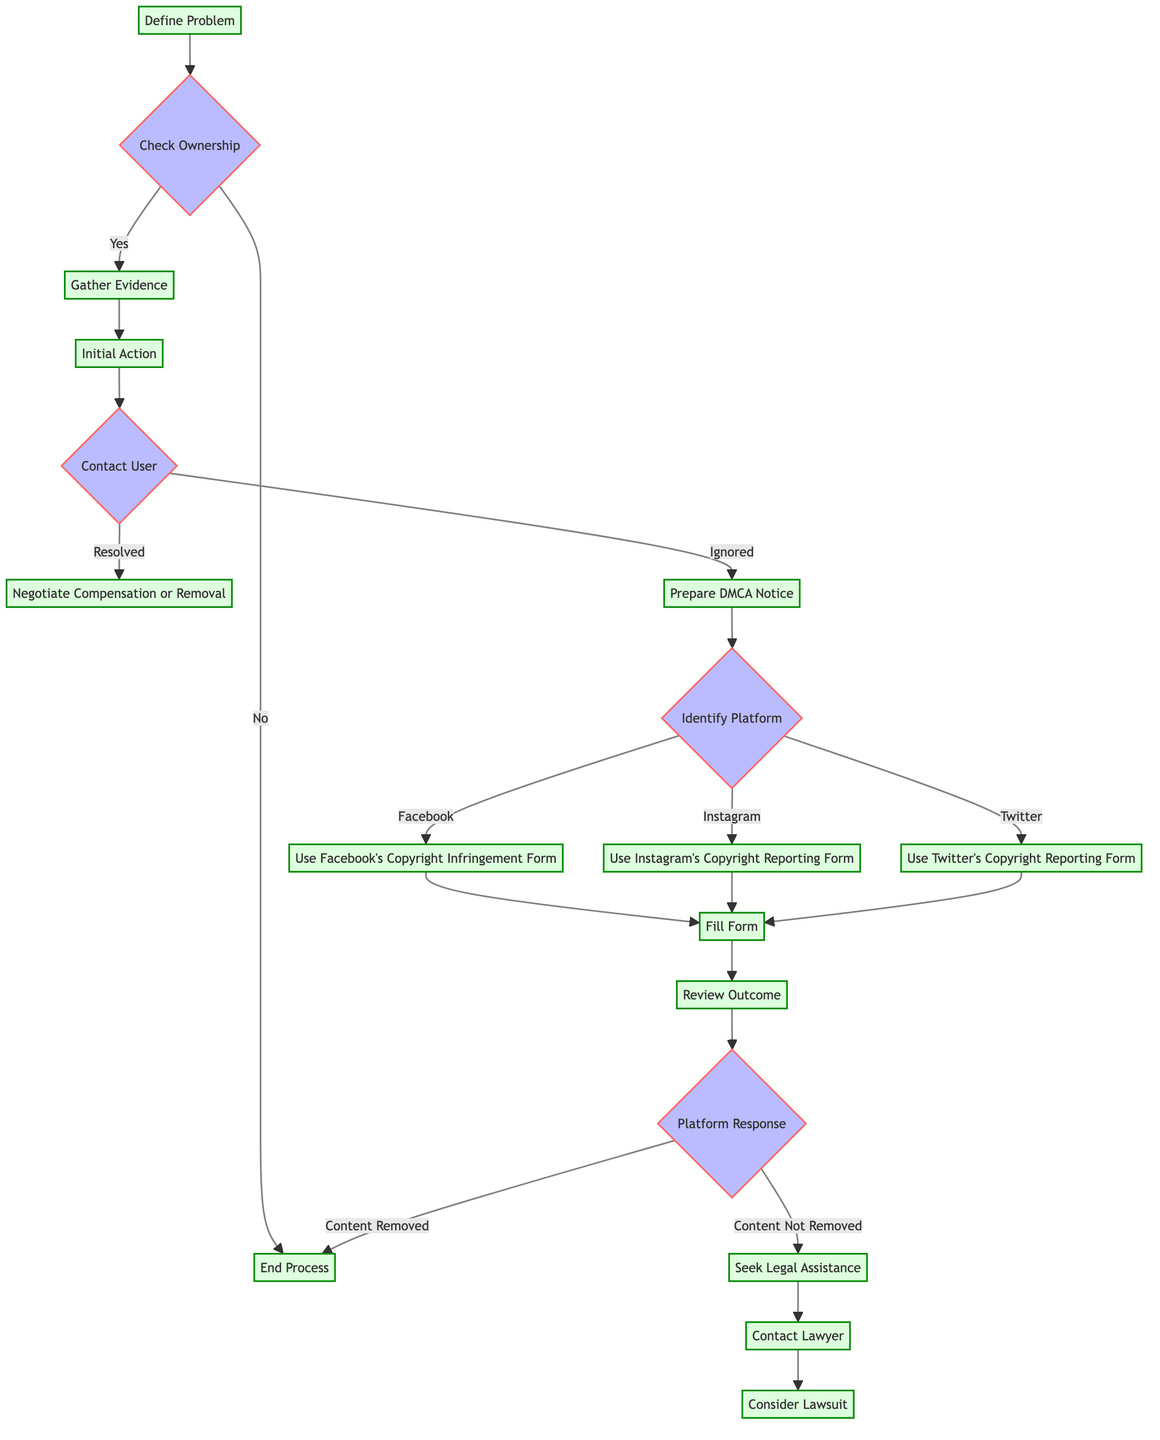What is the first action to take after defining the problem? After defining the problem, the next action is to check ownership of the photograph to confirm if it belongs to you or your client.
Answer: Check Ownership What happens if the ownership check is 'No'? If the ownership check is 'No', the process will end, indicating there is no further action to take regarding the unauthorized use of the photograph.
Answer: End Process Which evidence is collected to support the case? The evidence collected includes EXIF data metadata from the original photograph, documentation of publication dates from your own website or portfolio, and screenshots of the unauthorized use on social media.
Answer: Metadata, Publish Dates, Screenshots What is the outcome if the user responds positively? If the user responds positively to the initial contact and resolves the issue, the next step will be to negotiate compensation or removal of the unauthorized use of the photograph.
Answer: Negotiate Compensation or Removal How many different social media platforms are identified for the DMCA notice preparation? Three social media platforms are identified for the DMCA notice preparation: Facebook, Instagram, and Twitter.
Answer: Three What steps should be taken if the social media platform does not remove the content? If the social media platform does not remove the content, the next steps involve seeking legal assistance, which includes contacting a lawyer and considering the feasibility of filing a lawsuit for copyright infringement.
Answer: Seek Legal Assistance What is the action taken after gathering evidence? After gathering evidence, the next action is to initiate contact with the user who has posted the photograph without authorization.
Answer: Initial Action What required elements must be submitted for the DMCA notice on Instagram? The required elements for the DMCA notice on Instagram include proof of ownership, the URL of the infringing content, and contact information.
Answer: Proof of Ownership, URL of Infringing Content, Contact Information 